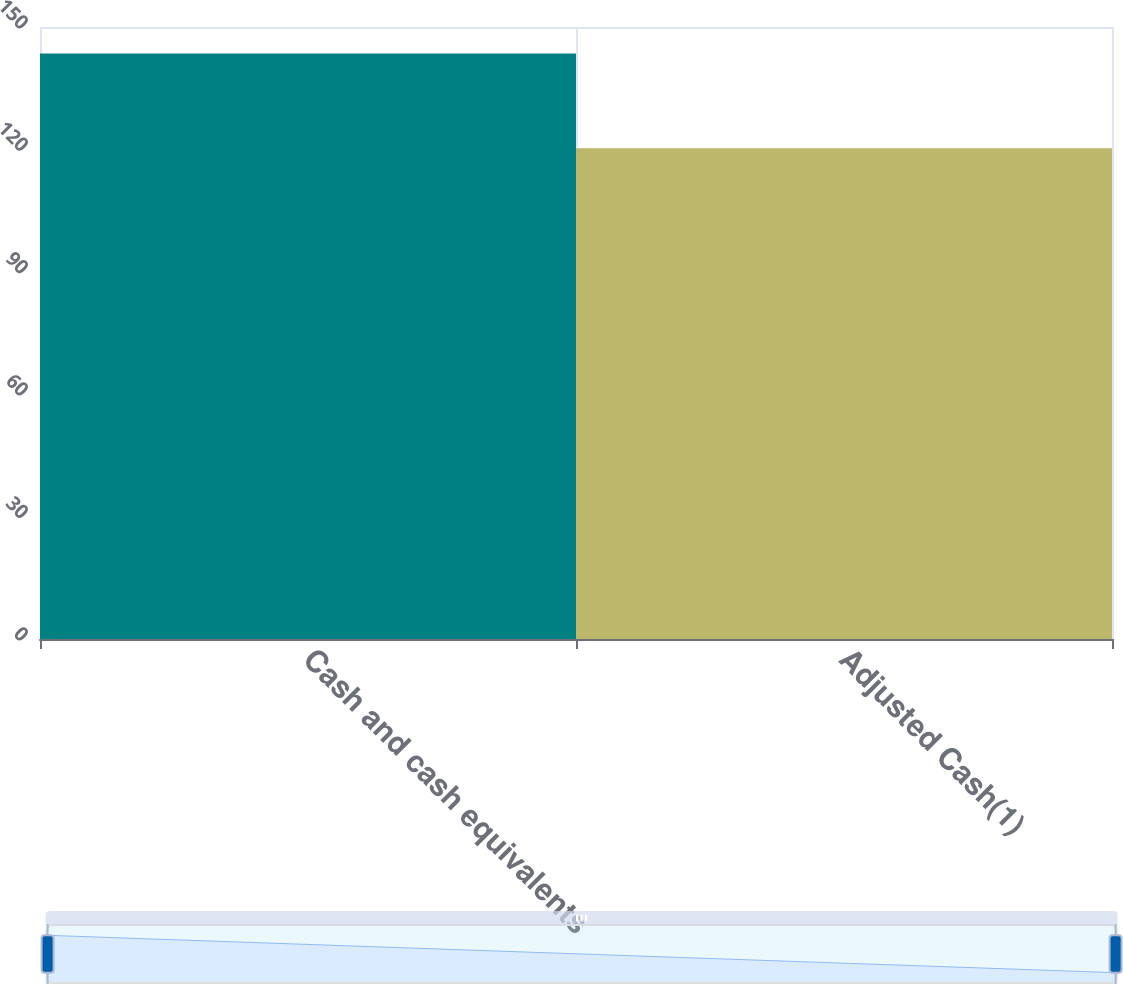Convert chart. <chart><loc_0><loc_0><loc_500><loc_500><bar_chart><fcel>Cash and cash equivalents<fcel>Adjusted Cash(1)<nl><fcel>143.5<fcel>120.3<nl></chart> 